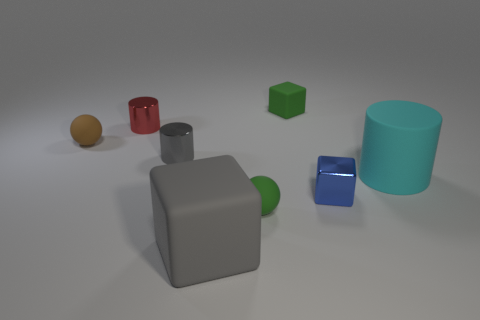There is a gray cube that is made of the same material as the big cyan object; what size is it?
Provide a succinct answer. Large. The tiny blue object has what shape?
Your answer should be very brief. Cube. Are the blue cube and the big object that is behind the tiny green rubber sphere made of the same material?
Keep it short and to the point. No. How many things are either red metallic things or green matte spheres?
Your response must be concise. 2. Are any tiny gray cylinders visible?
Ensure brevity in your answer.  Yes. The tiny thing behind the red thing that is to the left of the large gray block is what shape?
Make the answer very short. Cube. What number of things are big things to the left of the big cylinder or tiny objects to the left of the blue metallic block?
Your answer should be very brief. 6. There is a brown sphere that is the same size as the blue metal object; what is it made of?
Offer a terse response. Rubber. What is the color of the tiny rubber block?
Your answer should be very brief. Green. There is a small object that is both to the left of the small gray metal object and in front of the red metal cylinder; what is its material?
Your answer should be compact. Rubber. 